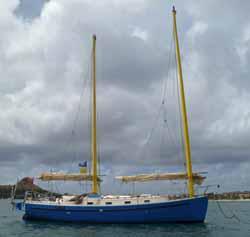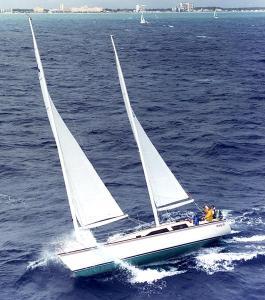The first image is the image on the left, the second image is the image on the right. Considering the images on both sides, is "All the boats are heading in the same direction." valid? Answer yes or no. No. The first image is the image on the left, the second image is the image on the right. Examine the images to the left and right. Is the description "One image features a boat with a blue-looking body, and the other image shows a boat with the upright masts of two triangular white sails on the left." accurate? Answer yes or no. Yes. 